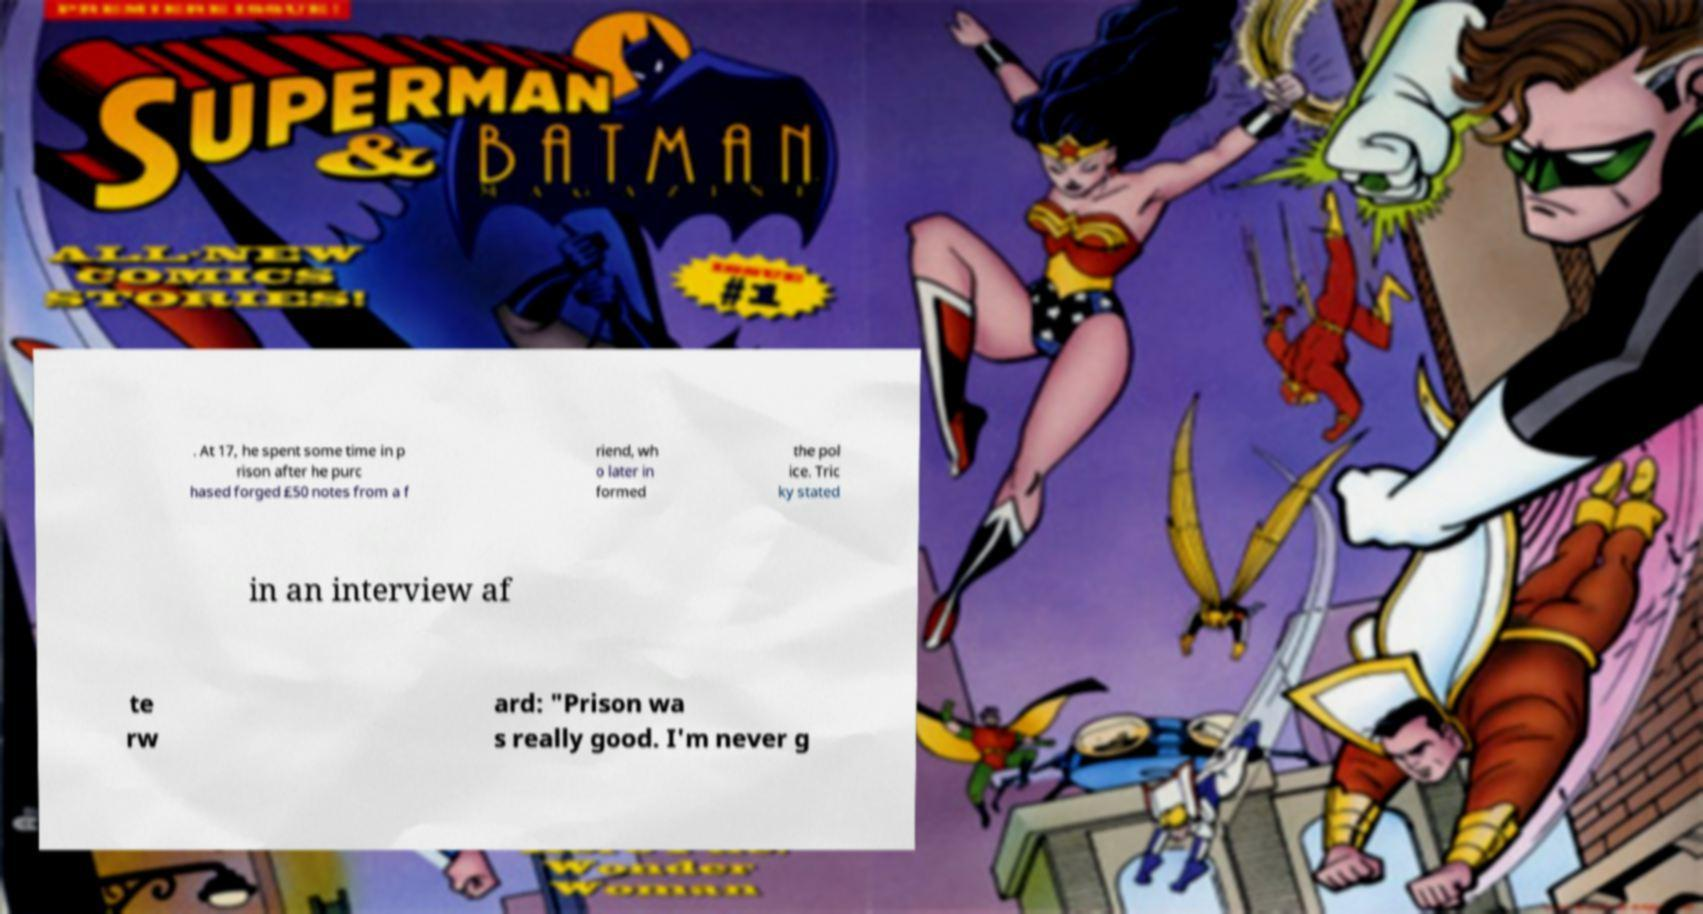For documentation purposes, I need the text within this image transcribed. Could you provide that? . At 17, he spent some time in p rison after he purc hased forged £50 notes from a f riend, wh o later in formed the pol ice. Tric ky stated in an interview af te rw ard: "Prison wa s really good. I'm never g 